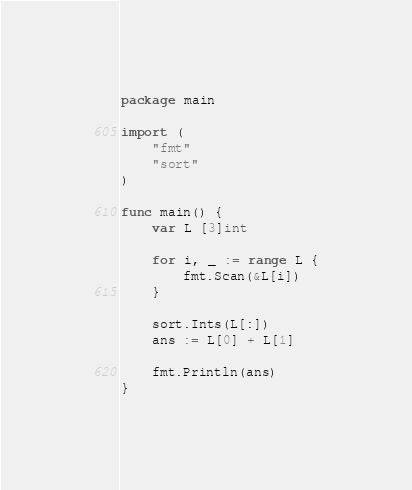Convert code to text. <code><loc_0><loc_0><loc_500><loc_500><_Go_>package main

import (
	"fmt"
	"sort"
)

func main() {
	var L [3]int

	for i, _ := range L {
		fmt.Scan(&L[i])
	}

	sort.Ints(L[:])
	ans := L[0] + L[1]

	fmt.Println(ans)
}
</code> 